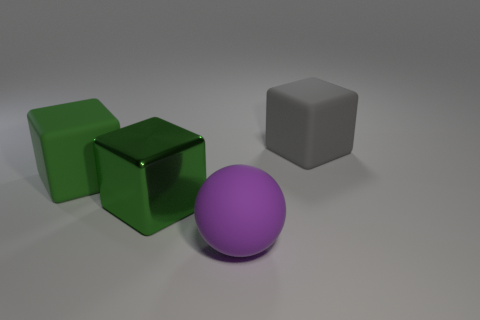There is another cube that is the same color as the metal cube; what material is it?
Provide a short and direct response. Rubber. How many things are matte cubes that are to the right of the sphere or large purple metallic cylinders?
Make the answer very short. 1. There is a block that is to the right of the purple rubber ball; is it the same size as the green shiny cube?
Give a very brief answer. Yes. Is the number of big green cubes that are on the right side of the purple rubber ball less than the number of red rubber objects?
Provide a succinct answer. No. There is a purple sphere that is the same size as the shiny block; what material is it?
Offer a terse response. Rubber. What number of large objects are green cubes or cyan cylinders?
Ensure brevity in your answer.  2. How many things are big green things behind the green metallic object or blocks on the right side of the green matte object?
Provide a short and direct response. 3. Is the number of yellow matte objects less than the number of big gray cubes?
Keep it short and to the point. Yes. The gray thing that is the same size as the purple matte ball is what shape?
Provide a short and direct response. Cube. How many other things are there of the same color as the large shiny block?
Your answer should be compact. 1. 